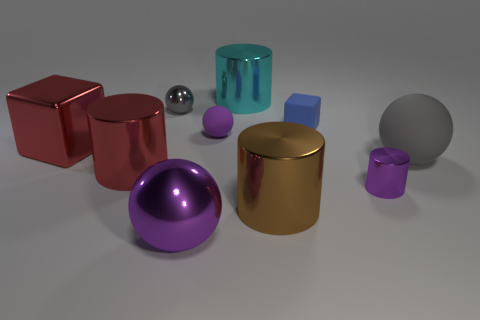There is a gray object to the right of the small purple cylinder; does it have the same shape as the tiny metal object that is behind the purple metal cylinder? Yes, the gray object to the right of the small purple cylinder has the same spherical shape as the tiny metal sphere that is located behind the larger purple metal cylinder. 